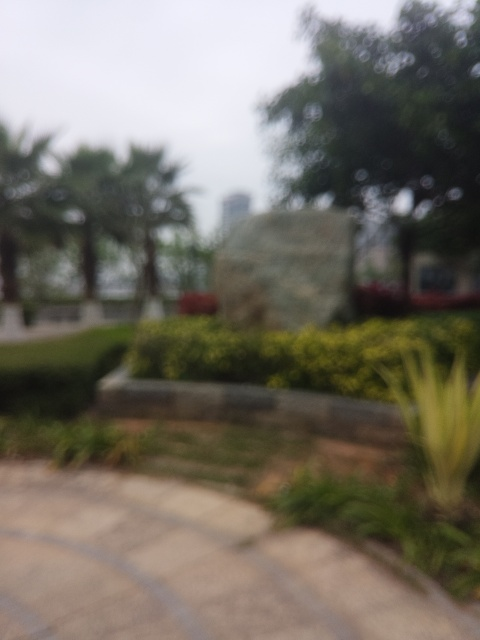What is the overall sharpness of this image? The overall sharpness of the image is very low. It appears quite blurred, making it difficult to discern the finer details of the scene. This level of blurriness could be indicative of either a deliberate use of a shallow depth of field by the photographer or a camera mishap, such as an accidental movement during the shot or a focus error. 